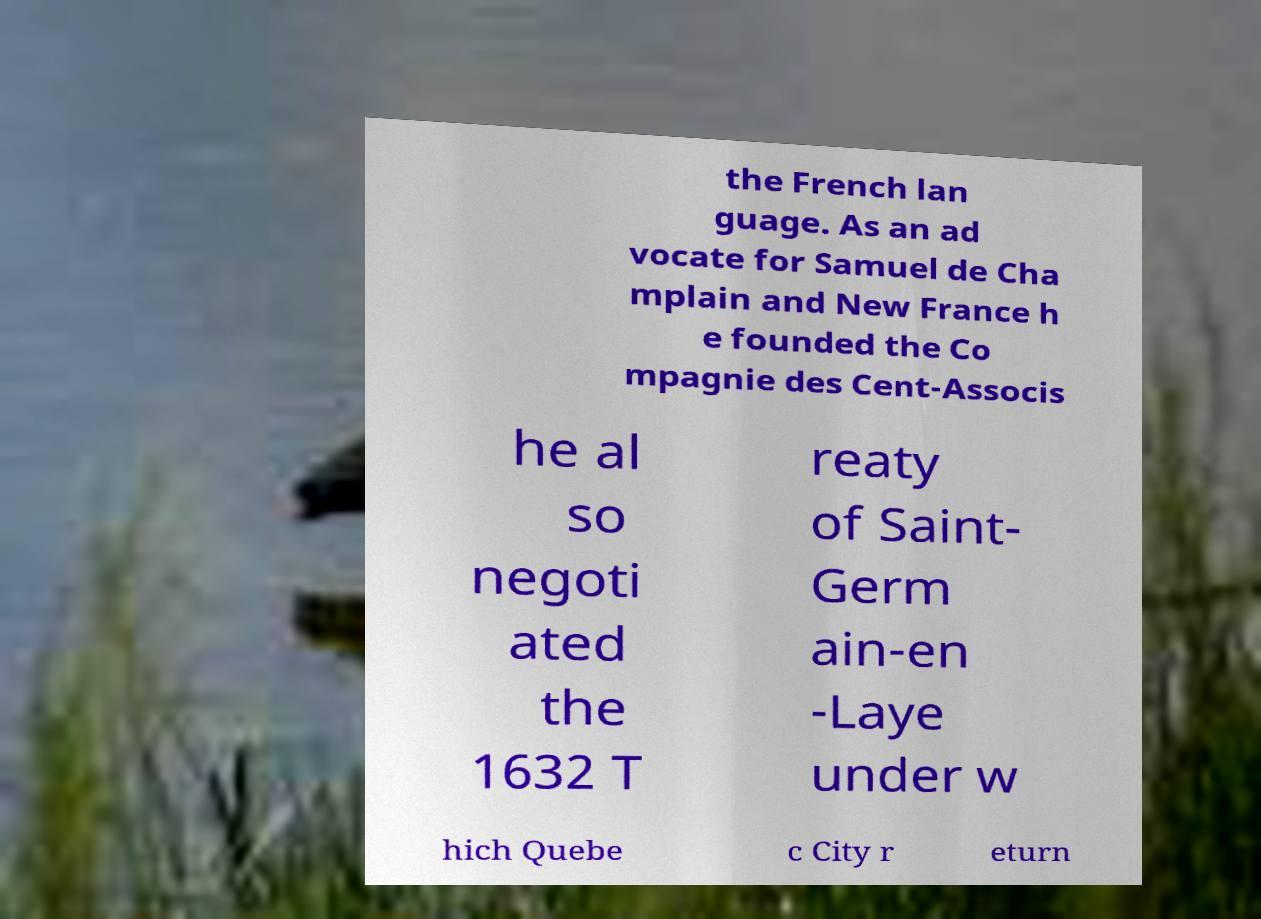For documentation purposes, I need the text within this image transcribed. Could you provide that? the French lan guage. As an ad vocate for Samuel de Cha mplain and New France h e founded the Co mpagnie des Cent-Associs he al so negoti ated the 1632 T reaty of Saint- Germ ain-en -Laye under w hich Quebe c City r eturn 